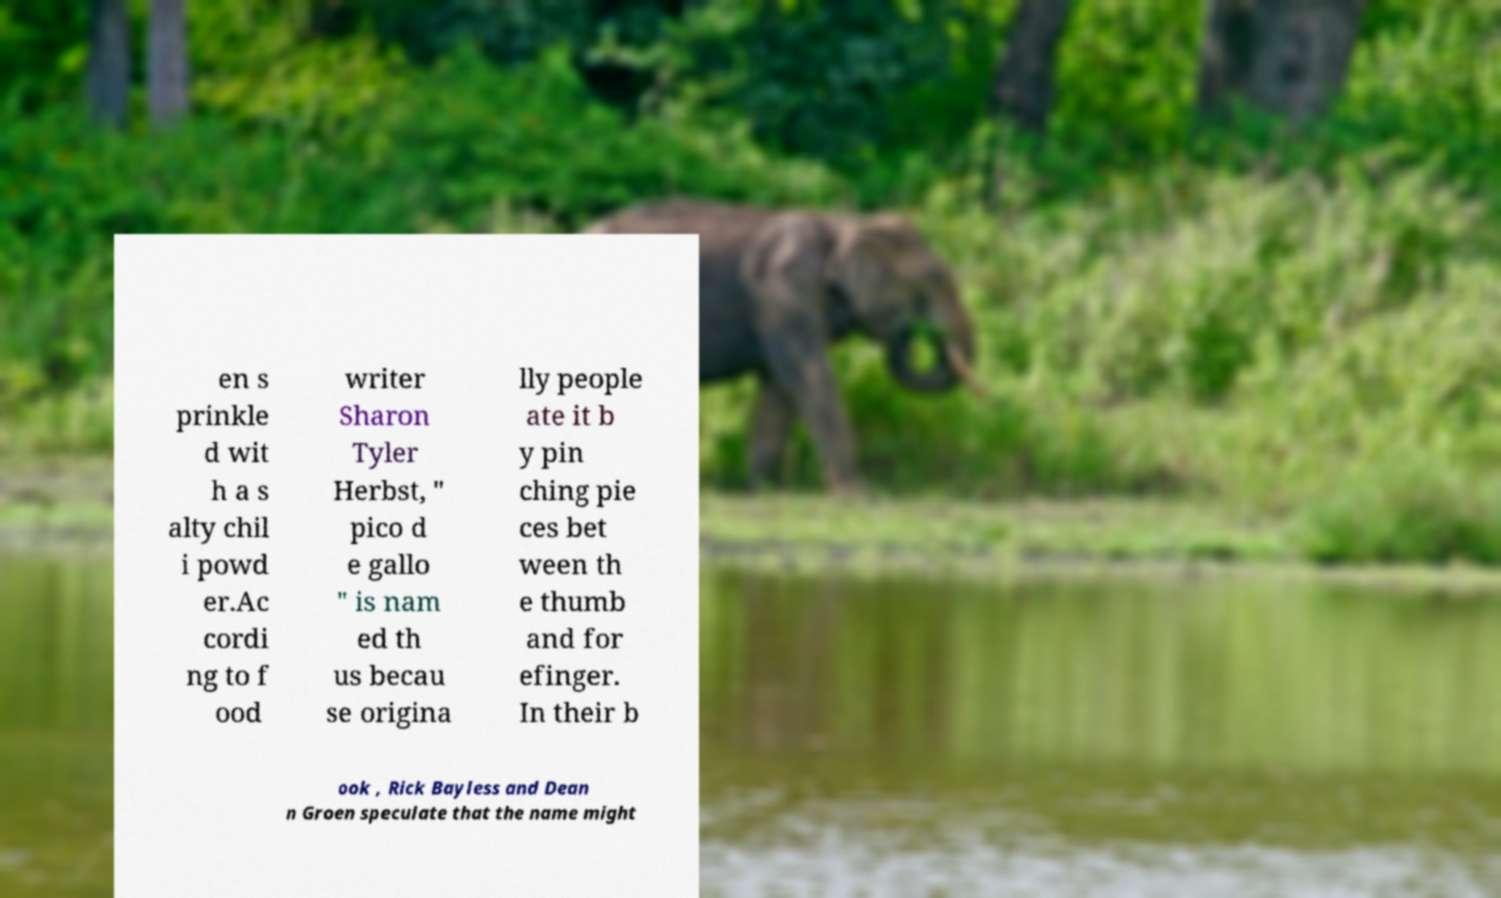Can you read and provide the text displayed in the image?This photo seems to have some interesting text. Can you extract and type it out for me? en s prinkle d wit h a s alty chil i powd er.Ac cordi ng to f ood writer Sharon Tyler Herbst, " pico d e gallo " is nam ed th us becau se origina lly people ate it b y pin ching pie ces bet ween th e thumb and for efinger. In their b ook , Rick Bayless and Dean n Groen speculate that the name might 